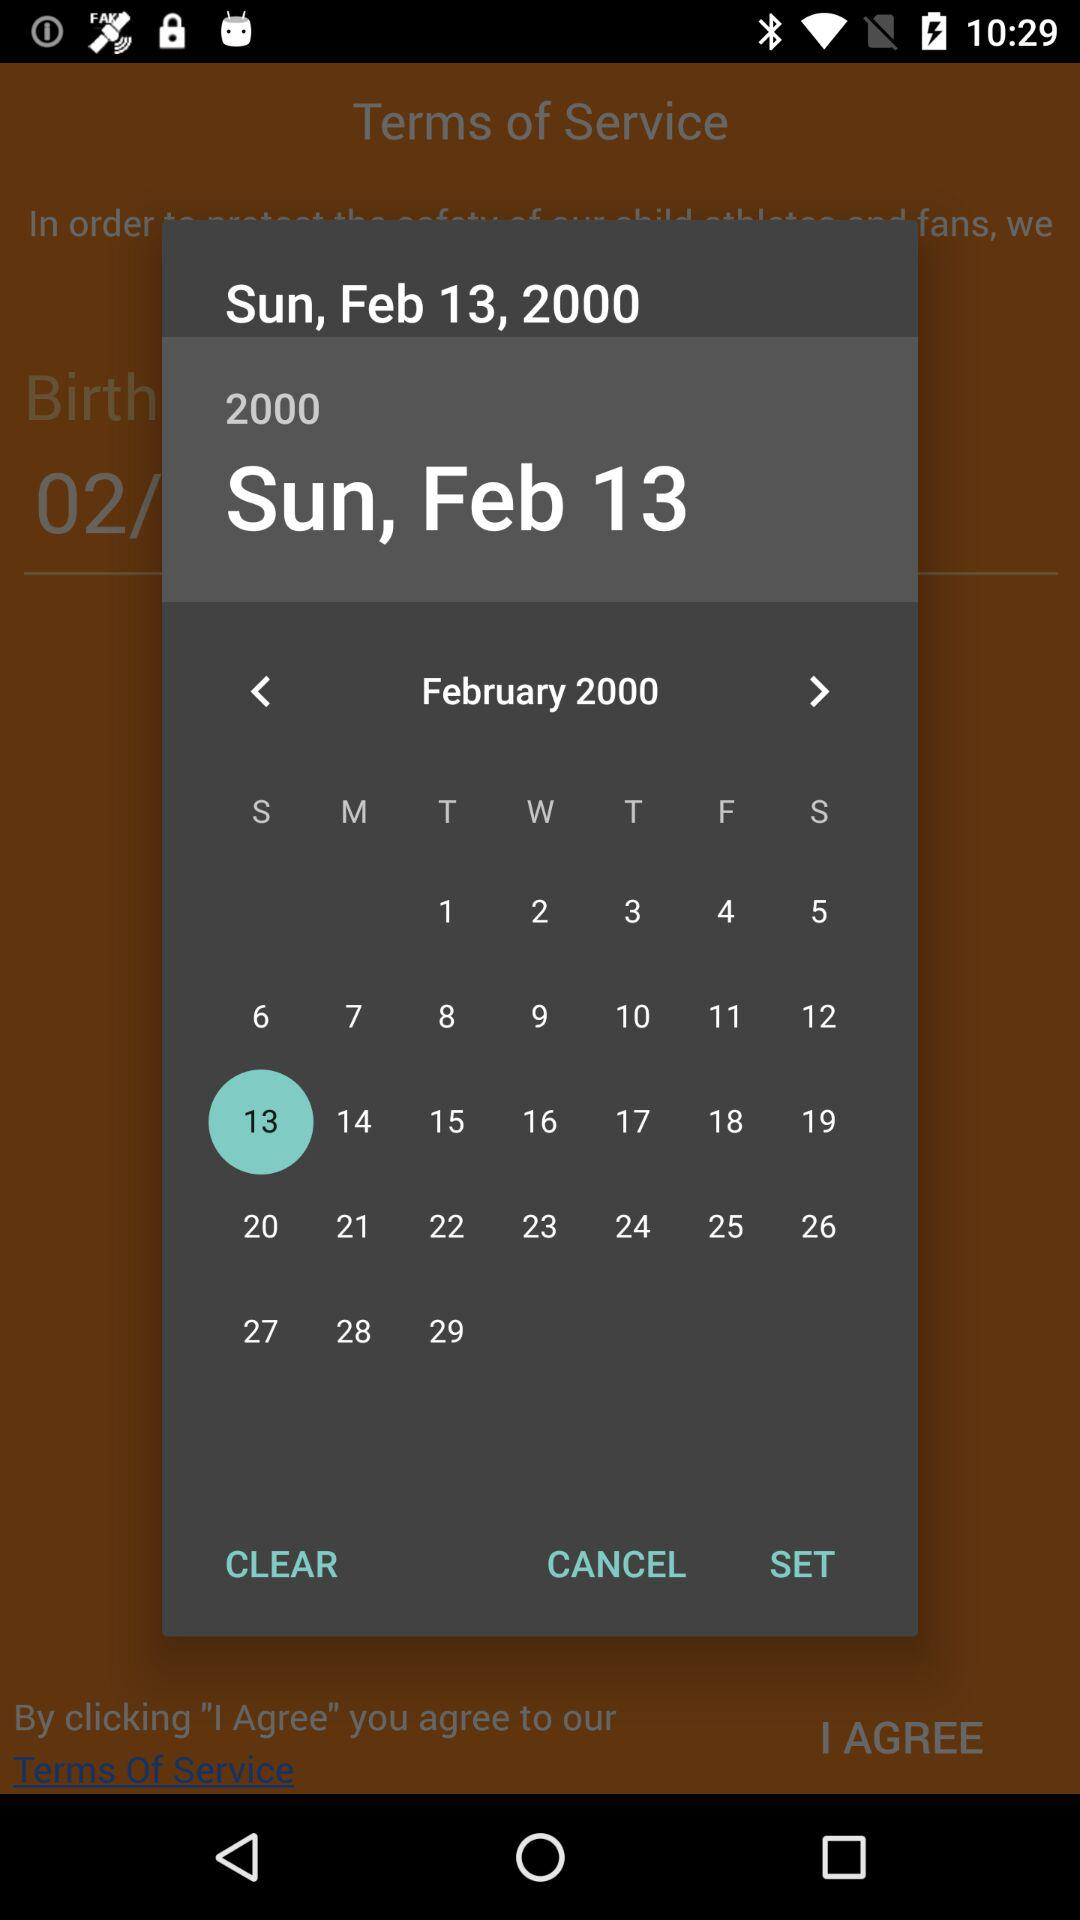What month of the calendar is it? It is the month of February. 